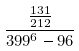<formula> <loc_0><loc_0><loc_500><loc_500>\frac { \frac { 1 3 1 } { 2 1 2 } } { 3 9 9 ^ { 6 } - 9 6 }</formula> 